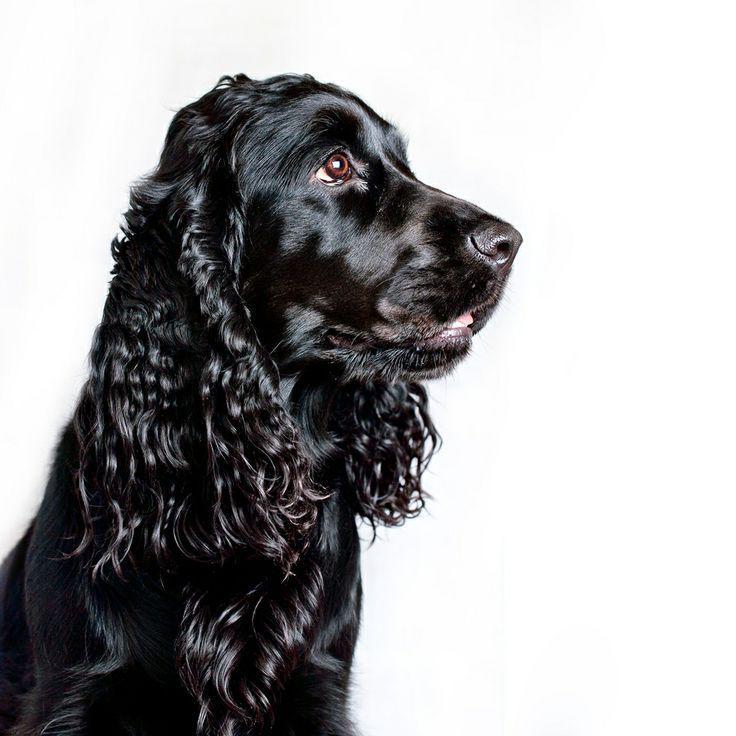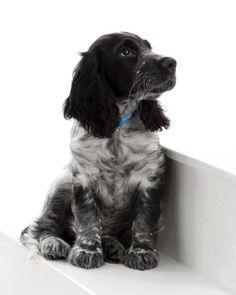The first image is the image on the left, the second image is the image on the right. Assess this claim about the two images: "One dog is not in a sitting position.". Correct or not? Answer yes or no. No. The first image is the image on the left, the second image is the image on the right. Examine the images to the left and right. Is the description "Left image features one dog sitting with head and body turned leftward." accurate? Answer yes or no. No. 